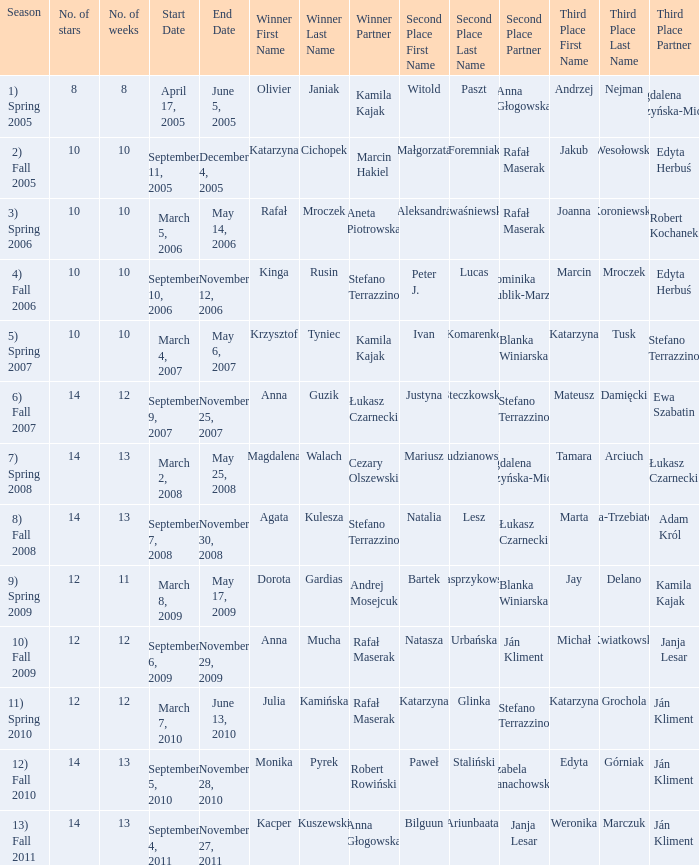Write the full table. {'header': ['Season', 'No. of stars', 'No. of weeks', 'Start Date', 'End Date', 'Winner First Name', 'Winner Last Name', 'Winner Partner', 'Second Place First Name', 'Second Place Last Name', 'Second Place Partner', 'Third Place First Name', 'Third Place Last Name', 'Third Place Partner'], 'rows': [['1) Spring 2005', '8', '8', 'April 17, 2005', 'June 5, 2005', 'Olivier', 'Janiak', 'Kamila Kajak', 'Witold', 'Paszt', 'Anna Głogowska', 'Andrzej', 'Nejman', 'Magdalena Soszyńska-Michno'], ['2) Fall 2005', '10', '10', 'September 11, 2005', 'December 4, 2005', 'Katarzyna', 'Cichopek', 'Marcin Hakiel', 'Małgorzata', 'Foremniak', 'Rafał Maserak', 'Jakub', 'Wesołowski', 'Edyta Herbuś'], ['3) Spring 2006', '10', '10', 'March 5, 2006', 'May 14, 2006', 'Rafał', 'Mroczek', 'Aneta Piotrowska', 'Aleksandra', 'Kwaśniewska', 'Rafał Maserak', 'Joanna', 'Koroniewska', 'Robert Kochanek'], ['4) Fall 2006', '10', '10', 'September 10, 2006', 'November 12, 2006', 'Kinga', 'Rusin', 'Stefano Terrazzino', 'Peter J.', 'Lucas', 'Dominika Kublik-Marzec', 'Marcin', 'Mroczek', 'Edyta Herbuś'], ['5) Spring 2007', '10', '10', 'March 4, 2007', 'May 6, 2007', 'Krzysztof', 'Tyniec', 'Kamila Kajak', 'Ivan', 'Komarenko', 'Blanka Winiarska', 'Katarzyna', 'Tusk', 'Stefano Terrazzino'], ['6) Fall 2007', '14', '12', 'September 9, 2007', 'November 25, 2007', 'Anna', 'Guzik', 'Łukasz Czarnecki', 'Justyna', 'Steczkowska', 'Stefano Terrazzino', 'Mateusz', 'Damięcki', 'Ewa Szabatin'], ['7) Spring 2008', '14', '13', 'March 2, 2008', 'May 25, 2008', 'Magdalena', 'Walach', 'Cezary Olszewski', 'Mariusz', 'Pudzianowski', 'Magdalena Soszyńska-Michno', 'Tamara', 'Arciuch', 'Łukasz Czarnecki'], ['8) Fall 2008', '14', '13', 'September 7, 2008', 'November 30, 2008', 'Agata', 'Kulesza', 'Stefano Terrazzino', 'Natalia', 'Lesz', 'Łukasz Czarnecki', 'Marta', 'Żmuda-Trzebiatowska', 'Adam Król'], ['9) Spring 2009', '12', '11', 'March 8, 2009', 'May 17, 2009', 'Dorota', 'Gardias', 'Andrej Mosejcuk', 'Bartek', 'Kasprzykowski', 'Blanka Winiarska', 'Jay', 'Delano', 'Kamila Kajak'], ['10) Fall 2009', '12', '12', 'September 6, 2009', 'November 29, 2009', 'Anna', 'Mucha', 'Rafał Maserak', 'Natasza', 'Urbańska', 'Ján Kliment', 'Michał', 'Kwiatkowski', 'Janja Lesar'], ['11) Spring 2010', '12', '12', 'March 7, 2010', 'June 13, 2010', 'Julia', 'Kamińska', 'Rafał Maserak', 'Katarzyna', 'Glinka', 'Stefano Terrazzino', 'Katarzyna', 'Grochola', 'Ján Kliment'], ['12) Fall 2010', '14', '13', 'September 5, 2010', 'November 28, 2010', 'Monika', 'Pyrek', 'Robert Rowiński', 'Paweł', 'Staliński', 'Izabela Janachowska', 'Edyta', 'Górniak', 'Ján Kliment'], ['13) Fall 2011', '14', '13', 'September 4, 2011', 'November 27, 2011', 'Kacper', 'Kuszewski', 'Anna Głogowska', 'Bilguun', 'Ariunbaatar', 'Janja Lesar', 'Weronika', 'Marczuk', 'Ján Kliment']]} Who got second place when the winners were rafał mroczek & aneta piotrowska? Aleksandra Kwaśniewska & Rafał Maserak. 